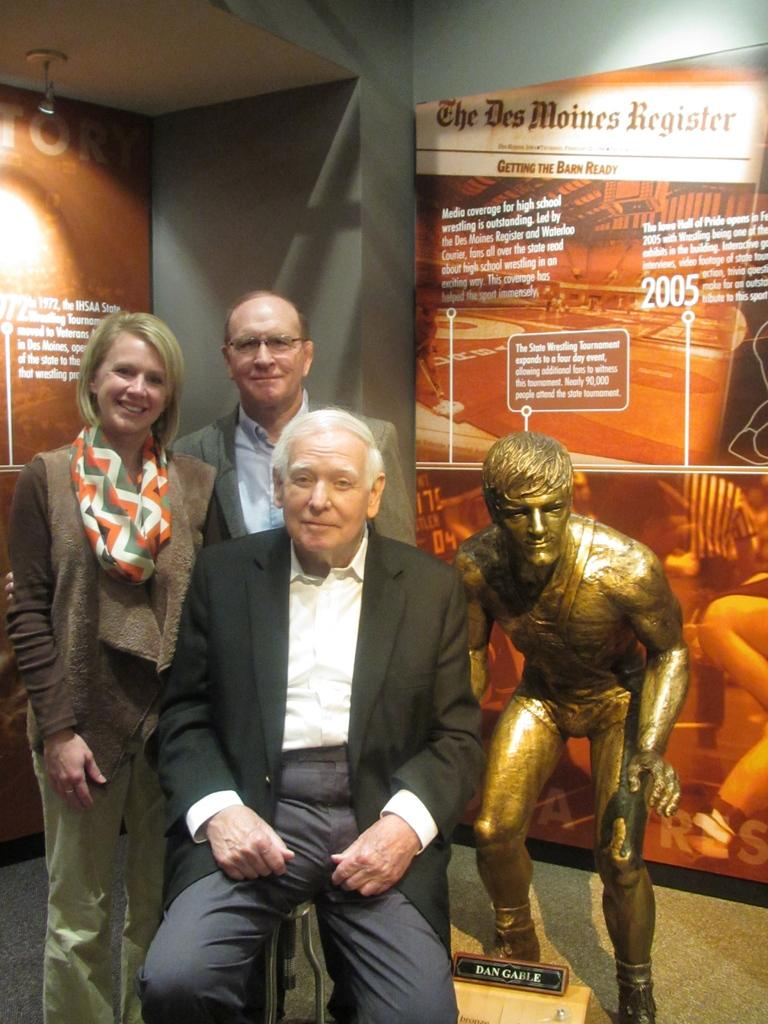How many people are in the image? There are three persons in the image. What else can be seen in the image besides the people? There is a sculpture in the image. What is visible in the background of the image? There are hoardings and a wall in the background of the image. What type of calculator is being used by the actor in the image? There is no actor or calculator present in the image. 